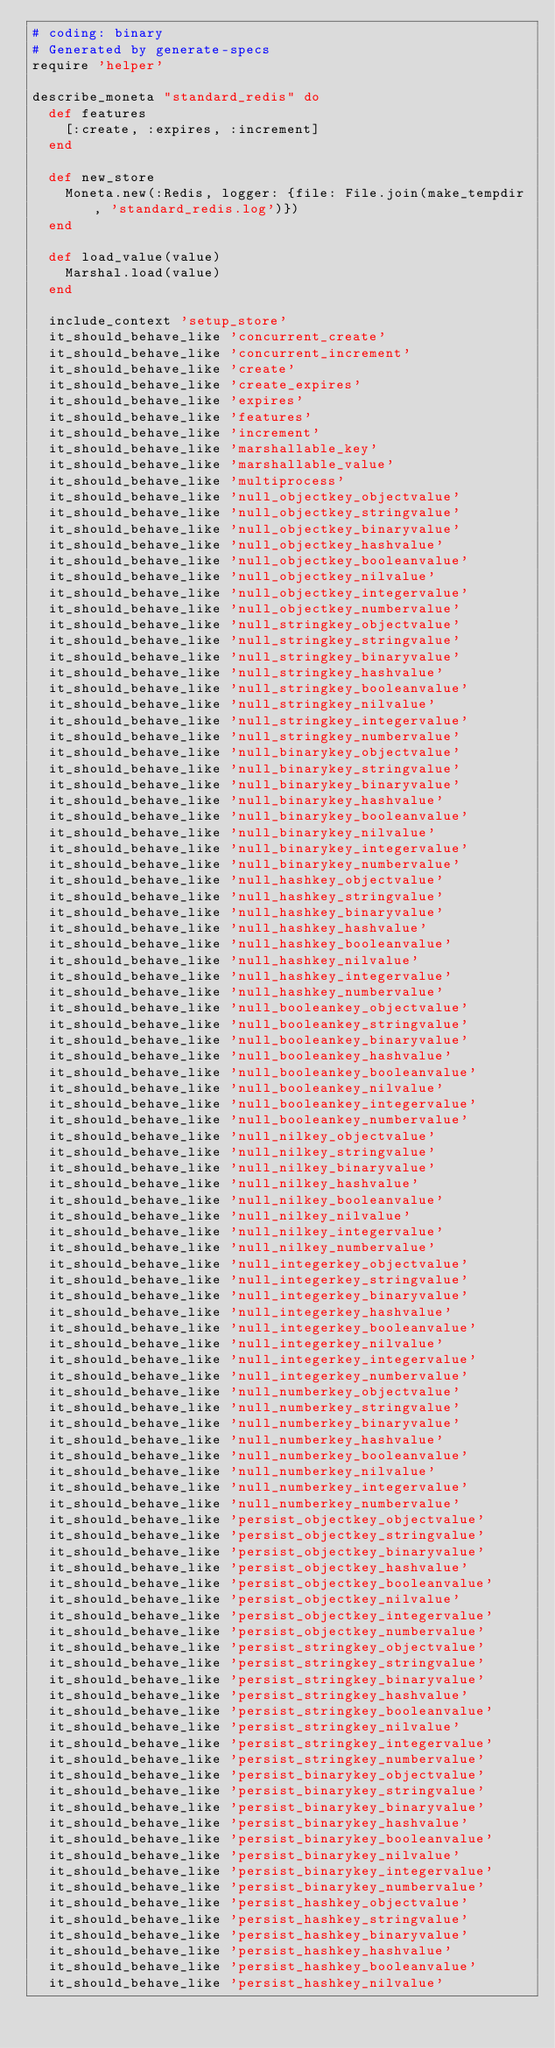Convert code to text. <code><loc_0><loc_0><loc_500><loc_500><_Ruby_># coding: binary
# Generated by generate-specs
require 'helper'

describe_moneta "standard_redis" do
  def features
    [:create, :expires, :increment]
  end

  def new_store
    Moneta.new(:Redis, logger: {file: File.join(make_tempdir, 'standard_redis.log')})
  end

  def load_value(value)
    Marshal.load(value)
  end

  include_context 'setup_store'
  it_should_behave_like 'concurrent_create'
  it_should_behave_like 'concurrent_increment'
  it_should_behave_like 'create'
  it_should_behave_like 'create_expires'
  it_should_behave_like 'expires'
  it_should_behave_like 'features'
  it_should_behave_like 'increment'
  it_should_behave_like 'marshallable_key'
  it_should_behave_like 'marshallable_value'
  it_should_behave_like 'multiprocess'
  it_should_behave_like 'null_objectkey_objectvalue'
  it_should_behave_like 'null_objectkey_stringvalue'
  it_should_behave_like 'null_objectkey_binaryvalue'
  it_should_behave_like 'null_objectkey_hashvalue'
  it_should_behave_like 'null_objectkey_booleanvalue'
  it_should_behave_like 'null_objectkey_nilvalue'
  it_should_behave_like 'null_objectkey_integervalue'
  it_should_behave_like 'null_objectkey_numbervalue'
  it_should_behave_like 'null_stringkey_objectvalue'
  it_should_behave_like 'null_stringkey_stringvalue'
  it_should_behave_like 'null_stringkey_binaryvalue'
  it_should_behave_like 'null_stringkey_hashvalue'
  it_should_behave_like 'null_stringkey_booleanvalue'
  it_should_behave_like 'null_stringkey_nilvalue'
  it_should_behave_like 'null_stringkey_integervalue'
  it_should_behave_like 'null_stringkey_numbervalue'
  it_should_behave_like 'null_binarykey_objectvalue'
  it_should_behave_like 'null_binarykey_stringvalue'
  it_should_behave_like 'null_binarykey_binaryvalue'
  it_should_behave_like 'null_binarykey_hashvalue'
  it_should_behave_like 'null_binarykey_booleanvalue'
  it_should_behave_like 'null_binarykey_nilvalue'
  it_should_behave_like 'null_binarykey_integervalue'
  it_should_behave_like 'null_binarykey_numbervalue'
  it_should_behave_like 'null_hashkey_objectvalue'
  it_should_behave_like 'null_hashkey_stringvalue'
  it_should_behave_like 'null_hashkey_binaryvalue'
  it_should_behave_like 'null_hashkey_hashvalue'
  it_should_behave_like 'null_hashkey_booleanvalue'
  it_should_behave_like 'null_hashkey_nilvalue'
  it_should_behave_like 'null_hashkey_integervalue'
  it_should_behave_like 'null_hashkey_numbervalue'
  it_should_behave_like 'null_booleankey_objectvalue'
  it_should_behave_like 'null_booleankey_stringvalue'
  it_should_behave_like 'null_booleankey_binaryvalue'
  it_should_behave_like 'null_booleankey_hashvalue'
  it_should_behave_like 'null_booleankey_booleanvalue'
  it_should_behave_like 'null_booleankey_nilvalue'
  it_should_behave_like 'null_booleankey_integervalue'
  it_should_behave_like 'null_booleankey_numbervalue'
  it_should_behave_like 'null_nilkey_objectvalue'
  it_should_behave_like 'null_nilkey_stringvalue'
  it_should_behave_like 'null_nilkey_binaryvalue'
  it_should_behave_like 'null_nilkey_hashvalue'
  it_should_behave_like 'null_nilkey_booleanvalue'
  it_should_behave_like 'null_nilkey_nilvalue'
  it_should_behave_like 'null_nilkey_integervalue'
  it_should_behave_like 'null_nilkey_numbervalue'
  it_should_behave_like 'null_integerkey_objectvalue'
  it_should_behave_like 'null_integerkey_stringvalue'
  it_should_behave_like 'null_integerkey_binaryvalue'
  it_should_behave_like 'null_integerkey_hashvalue'
  it_should_behave_like 'null_integerkey_booleanvalue'
  it_should_behave_like 'null_integerkey_nilvalue'
  it_should_behave_like 'null_integerkey_integervalue'
  it_should_behave_like 'null_integerkey_numbervalue'
  it_should_behave_like 'null_numberkey_objectvalue'
  it_should_behave_like 'null_numberkey_stringvalue'
  it_should_behave_like 'null_numberkey_binaryvalue'
  it_should_behave_like 'null_numberkey_hashvalue'
  it_should_behave_like 'null_numberkey_booleanvalue'
  it_should_behave_like 'null_numberkey_nilvalue'
  it_should_behave_like 'null_numberkey_integervalue'
  it_should_behave_like 'null_numberkey_numbervalue'
  it_should_behave_like 'persist_objectkey_objectvalue'
  it_should_behave_like 'persist_objectkey_stringvalue'
  it_should_behave_like 'persist_objectkey_binaryvalue'
  it_should_behave_like 'persist_objectkey_hashvalue'
  it_should_behave_like 'persist_objectkey_booleanvalue'
  it_should_behave_like 'persist_objectkey_nilvalue'
  it_should_behave_like 'persist_objectkey_integervalue'
  it_should_behave_like 'persist_objectkey_numbervalue'
  it_should_behave_like 'persist_stringkey_objectvalue'
  it_should_behave_like 'persist_stringkey_stringvalue'
  it_should_behave_like 'persist_stringkey_binaryvalue'
  it_should_behave_like 'persist_stringkey_hashvalue'
  it_should_behave_like 'persist_stringkey_booleanvalue'
  it_should_behave_like 'persist_stringkey_nilvalue'
  it_should_behave_like 'persist_stringkey_integervalue'
  it_should_behave_like 'persist_stringkey_numbervalue'
  it_should_behave_like 'persist_binarykey_objectvalue'
  it_should_behave_like 'persist_binarykey_stringvalue'
  it_should_behave_like 'persist_binarykey_binaryvalue'
  it_should_behave_like 'persist_binarykey_hashvalue'
  it_should_behave_like 'persist_binarykey_booleanvalue'
  it_should_behave_like 'persist_binarykey_nilvalue'
  it_should_behave_like 'persist_binarykey_integervalue'
  it_should_behave_like 'persist_binarykey_numbervalue'
  it_should_behave_like 'persist_hashkey_objectvalue'
  it_should_behave_like 'persist_hashkey_stringvalue'
  it_should_behave_like 'persist_hashkey_binaryvalue'
  it_should_behave_like 'persist_hashkey_hashvalue'
  it_should_behave_like 'persist_hashkey_booleanvalue'
  it_should_behave_like 'persist_hashkey_nilvalue'</code> 